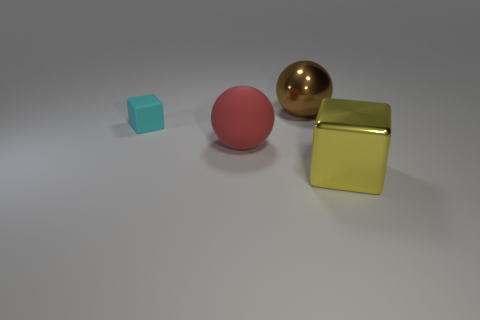Can you guess the relative sizes of these objects? While actual measurements are not possible from the image, relative to each other, the small cyan cube may be a few inches across, the pink sphere might be double that in diameter, and the golden sphere and the creamy metallic cube appear to be larger still, potentially around the same size and several inches in diameter.  Are the shadows telling us anything about the light source? Yes, the shadows, which are soft-edged and elongated, suggest that the light source is not directly overhead but instead at an angle to the objects. The angle and softness of the shadows indicate a diffused light source, not a very harsh one, which is possibly located above and to the front-right of the scene. 